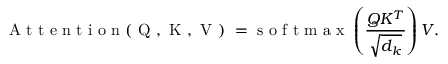<formula> <loc_0><loc_0><loc_500><loc_500>A t t e n t i o n ( Q , K , V ) = s o f t m a x \left ( \frac { Q K ^ { T } } { \sqrt { d _ { k } } } \right ) V .</formula> 